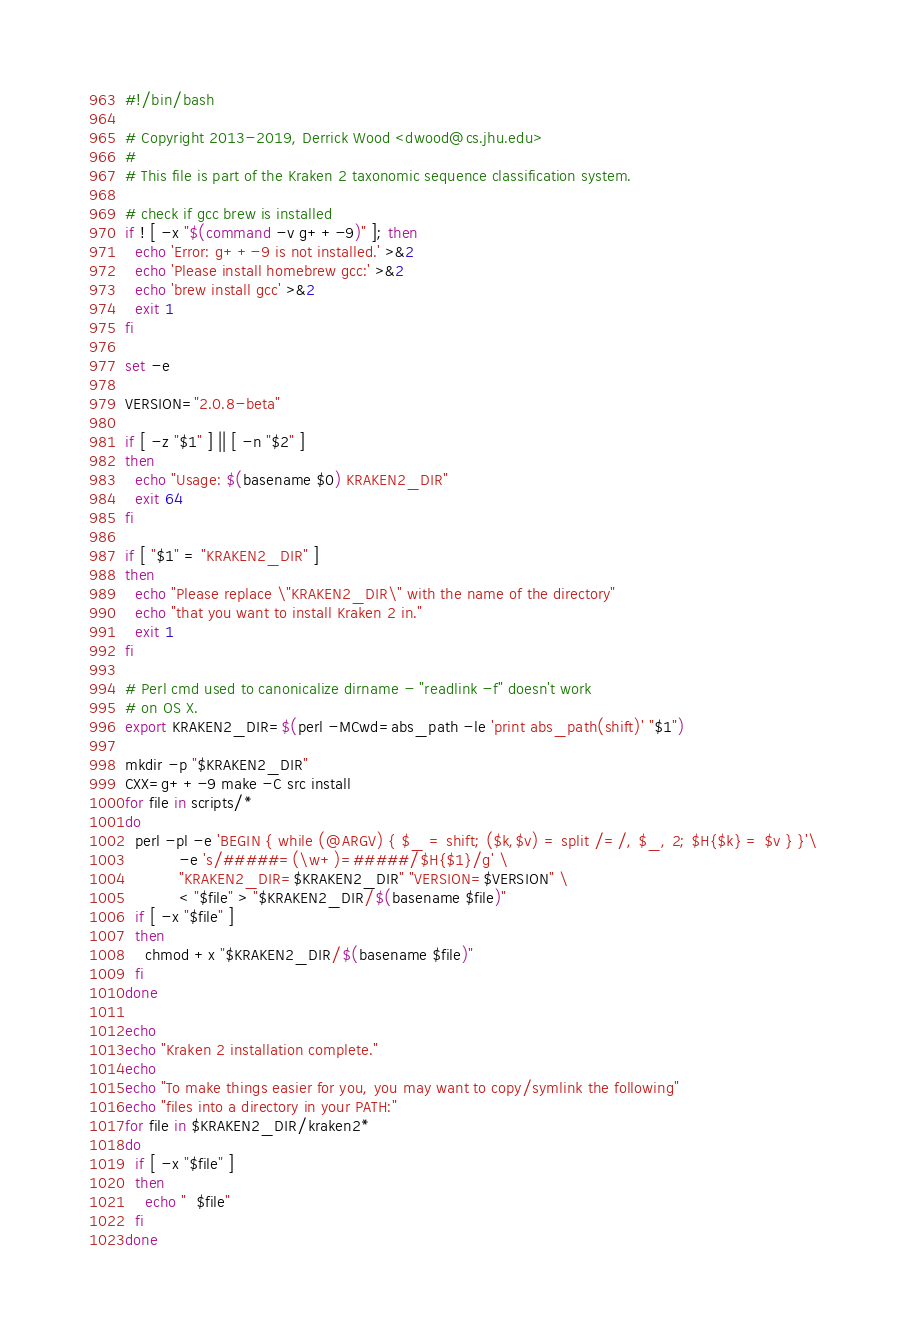Convert code to text. <code><loc_0><loc_0><loc_500><loc_500><_Bash_>#!/bin/bash

# Copyright 2013-2019, Derrick Wood <dwood@cs.jhu.edu>
#
# This file is part of the Kraken 2 taxonomic sequence classification system.

# check if gcc brew is installed
if ! [ -x "$(command -v g++-9)" ]; then
  echo 'Error: g++-9 is not installed.' >&2
  echo 'Please install homebrew gcc:' >&2
  echo 'brew install gcc' >&2
  exit 1
fi

set -e

VERSION="2.0.8-beta"

if [ -z "$1" ] || [ -n "$2" ]
then
  echo "Usage: $(basename $0) KRAKEN2_DIR"
  exit 64
fi

if [ "$1" = "KRAKEN2_DIR" ]
then
  echo "Please replace \"KRAKEN2_DIR\" with the name of the directory"
  echo "that you want to install Kraken 2 in."
  exit 1
fi

# Perl cmd used to canonicalize dirname - "readlink -f" doesn't work
# on OS X.
export KRAKEN2_DIR=$(perl -MCwd=abs_path -le 'print abs_path(shift)' "$1")

mkdir -p "$KRAKEN2_DIR"
CXX=g++-9 make -C src install
for file in scripts/*
do
  perl -pl -e 'BEGIN { while (@ARGV) { $_ = shift; ($k,$v) = split /=/, $_, 2; $H{$k} = $v } }'\
           -e 's/#####=(\w+)=#####/$H{$1}/g' \
           "KRAKEN2_DIR=$KRAKEN2_DIR" "VERSION=$VERSION" \
           < "$file" > "$KRAKEN2_DIR/$(basename $file)"
  if [ -x "$file" ]
  then
    chmod +x "$KRAKEN2_DIR/$(basename $file)"
  fi
done

echo
echo "Kraken 2 installation complete."
echo
echo "To make things easier for you, you may want to copy/symlink the following"
echo "files into a directory in your PATH:"
for file in $KRAKEN2_DIR/kraken2*
do
  if [ -x "$file" ]
  then
    echo "  $file"
  fi
done
</code> 